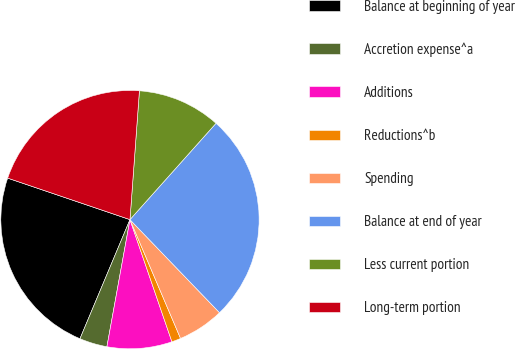Convert chart. <chart><loc_0><loc_0><loc_500><loc_500><pie_chart><fcel>Balance at beginning of year<fcel>Accretion expense^a<fcel>Additions<fcel>Reductions^b<fcel>Spending<fcel>Balance at end of year<fcel>Less current portion<fcel>Long-term portion<nl><fcel>23.88%<fcel>3.47%<fcel>8.12%<fcel>1.14%<fcel>5.79%<fcel>26.2%<fcel>10.44%<fcel>20.96%<nl></chart> 